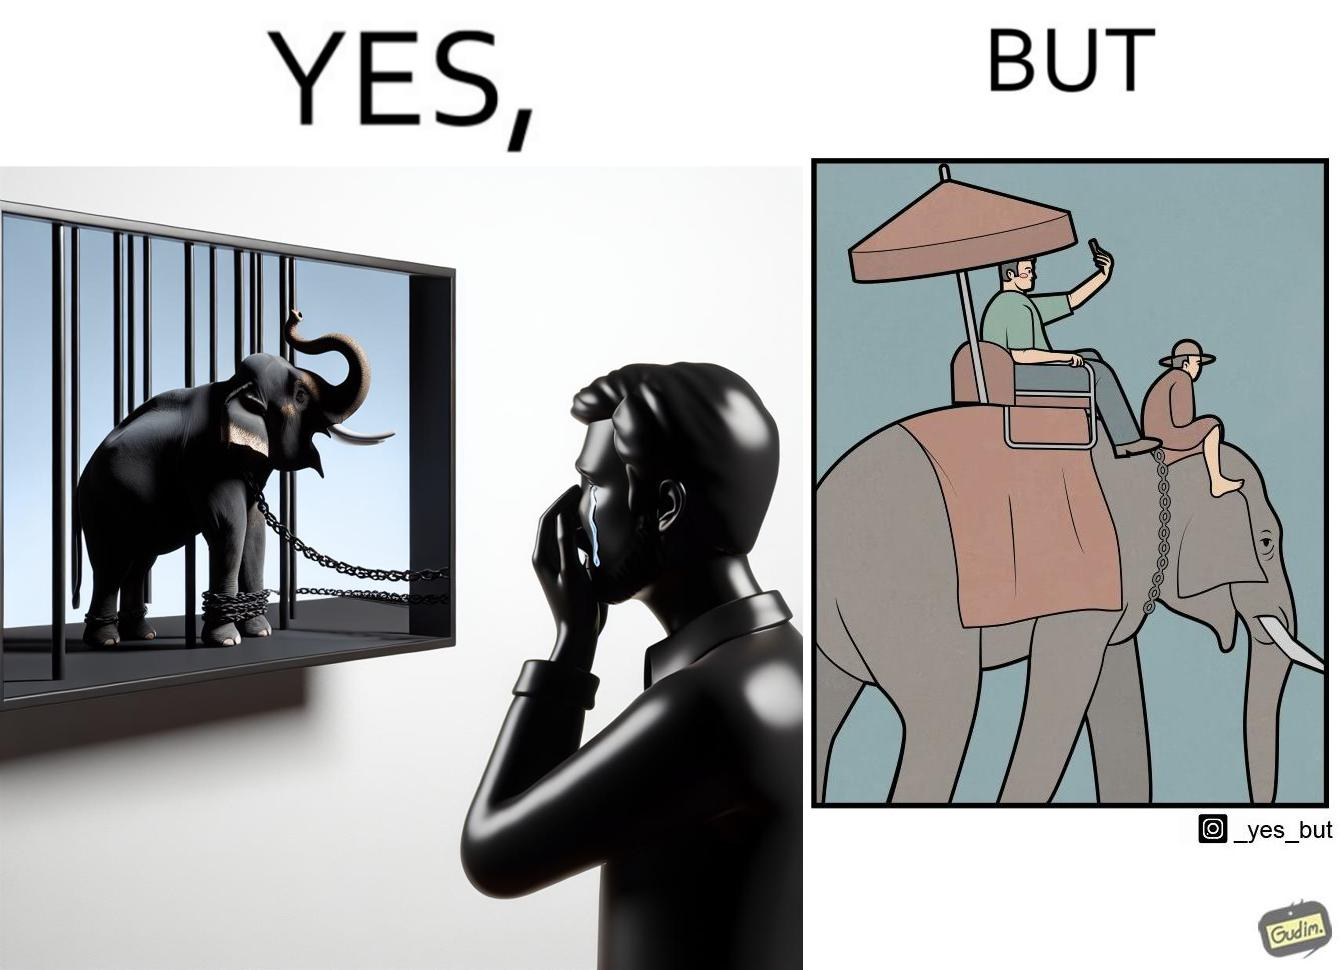Does this image contain satire or humor? Yes, this image is satirical. 